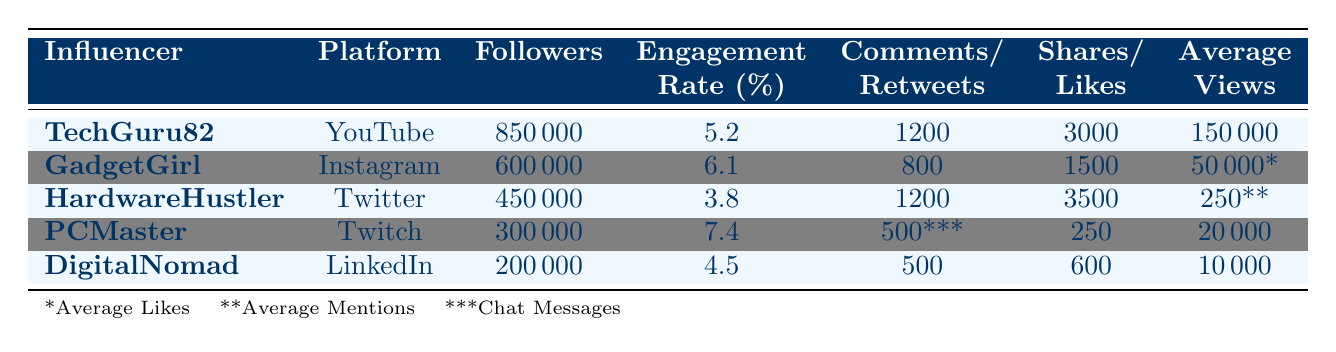What is the engagement rate of TechGuru82? The engagement rate for TechGuru82 is directly listed in the table under the "Engagement Rate (%)" column, which shows a value of 5.2%.
Answer: 5.2 Which influencer has the highest number of shares? To find the highest number of shares, I compare the "Shares" column for all influencers. TechGuru82 has 3000 shares, which is greater than GadgetGirl (1500), HardwareHustler (3500), PCMaster (250), and DigitalNomad (600). Therefore, TechGuru82 has the highest number of shares.
Answer: TechGuru82 What is the average engagement rate of all influencers listed in the table? The engagement rates for the influencers are 5.2, 6.1, 3.8, 7.4, and 4.5. To find the average, I sum these values: (5.2 + 6.1 + 3.8 + 7.4 + 4.5) = 27. The total number of influencers is 5, so the average engagement rate is 27 / 5 = 5.4.
Answer: 5.4 Does DigitalNomad have more followers than PCMaster? The table lists DigitalNomad's followers as 200000 and PCMaster's as 300000. Since 200000 is less than 300000, DigitalNomad does not have more followers than PCMaster.
Answer: No Which platform has the lowest engagement rate among the influencers? To find the platform with the lowest engagement rate, I look at the "Engagement Rate (%)" column. The rates are 5.2, 6.1, 3.8, 7.4, and 4.5. The lowest is 3.8 for HardwareHustler on Twitter, so that is the platform with the lowest engagement rate.
Answer: Twitter How many total comments did all influencers receive? I can find the total number of comments by adding the "Comments" column for all influencers: (1200 + 800 + 1200 + 500 + 500) = 3200. Therefore, the total number of comments received by all influencers is 3200.
Answer: 3200 Does GadgetGirl have a higher engagement rate than HardwareHustler? The engagement rate for GadgetGirl is 6.1%, while for HardwareHustler it is 3.8%. Since 6.1 is greater than 3.8, GadgetGirl does have a higher engagement rate than HardwareHustler.
Answer: Yes What is the ratio of shares to comments for TechGuru82? The shares for TechGuru82 are 3000 and comments are 1200. The ratio can be calculated as 3000 / 1200 = 2.5.
Answer: 2.5 Which influencer has the least average views, and what is that number? The "Average Views" column shows the average views for TechGuru82 (150000), GadgetGirl (50000), HardwareHustler (250), PCMaster (20000), and DigitalNomad (10000). The least average views is for HardwareHustler, with a total of 250 average views.
Answer: HardwareHustler, 250 